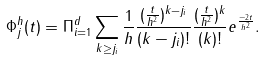Convert formula to latex. <formula><loc_0><loc_0><loc_500><loc_500>\Phi _ { j } ^ { h } ( t ) = \Pi _ { i = 1 } ^ { d } \sum _ { k \geq j _ { i } } \frac { 1 } { h } \frac { ( \frac { t } { h ^ { 2 } } ) ^ { k - j _ { i } } } { ( k - j _ { i } ) ! } \frac { ( \frac { t } { h ^ { 2 } } ) ^ { k } } { ( k ) ! } e ^ { \frac { - 2 t } { h ^ { 2 } } } .</formula> 